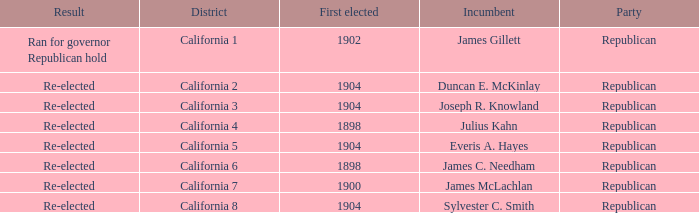Write the full table. {'header': ['Result', 'District', 'First elected', 'Incumbent', 'Party'], 'rows': [['Ran for governor Republican hold', 'California 1', '1902', 'James Gillett', 'Republican'], ['Re-elected', 'California 2', '1904', 'Duncan E. McKinlay', 'Republican'], ['Re-elected', 'California 3', '1904', 'Joseph R. Knowland', 'Republican'], ['Re-elected', 'California 4', '1898', 'Julius Kahn', 'Republican'], ['Re-elected', 'California 5', '1904', 'Everis A. Hayes', 'Republican'], ['Re-elected', 'California 6', '1898', 'James C. Needham', 'Republican'], ['Re-elected', 'California 7', '1900', 'James McLachlan', 'Republican'], ['Re-elected', 'California 8', '1904', 'Sylvester C. Smith', 'Republican']]} Which Incumbent has a District of California 8? Sylvester C. Smith. 